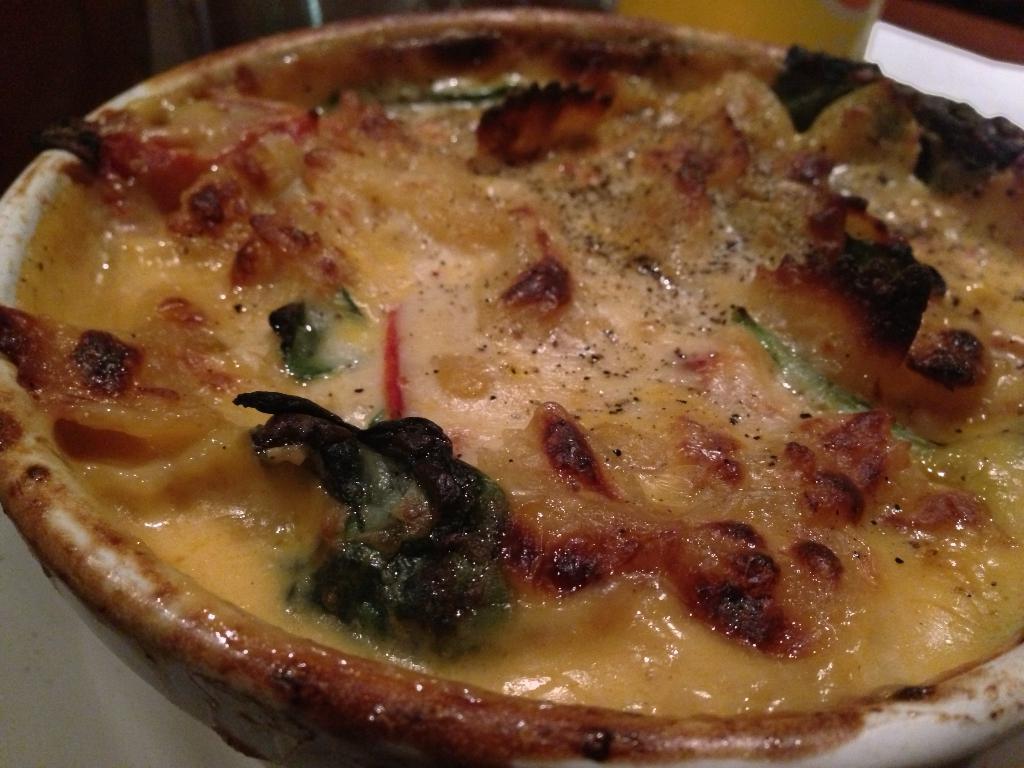How would you summarize this image in a sentence or two? Here we can see a food item in a bowl on a plate. In the background we can see an object. 